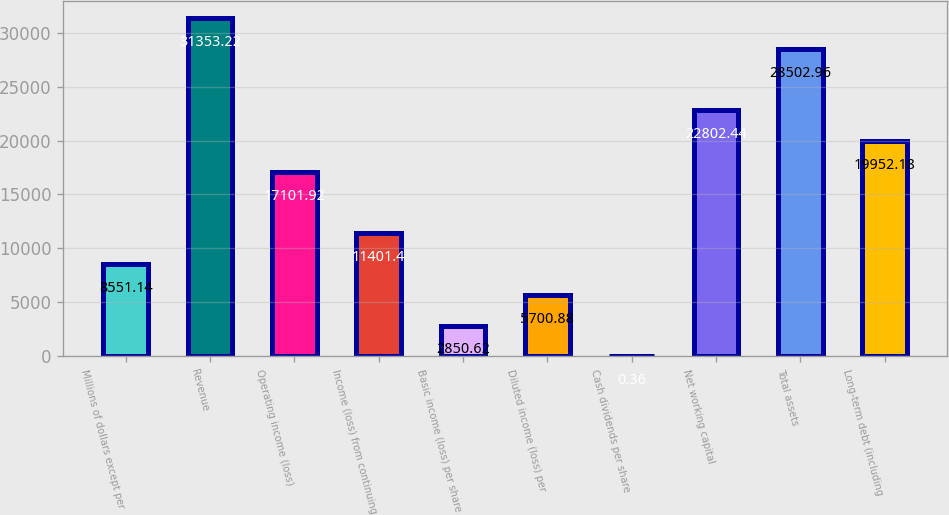Convert chart. <chart><loc_0><loc_0><loc_500><loc_500><bar_chart><fcel>Millions of dollars except per<fcel>Revenue<fcel>Operating income (loss)<fcel>Income (loss) from continuing<fcel>Basic income (loss) per share<fcel>Diluted income (loss) per<fcel>Cash dividends per share<fcel>Net working capital<fcel>Total assets<fcel>Long-term debt (including<nl><fcel>8551.14<fcel>31353.2<fcel>17101.9<fcel>11401.4<fcel>2850.62<fcel>5700.88<fcel>0.36<fcel>22802.4<fcel>28503<fcel>19952.2<nl></chart> 